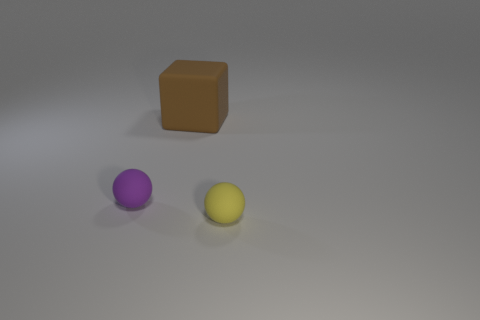Add 3 balls. How many objects exist? 6 Subtract all blocks. How many objects are left? 2 Add 3 tiny matte spheres. How many tiny matte spheres exist? 5 Subtract 0 cyan blocks. How many objects are left? 3 Subtract all small cyan cylinders. Subtract all purple matte things. How many objects are left? 2 Add 3 blocks. How many blocks are left? 4 